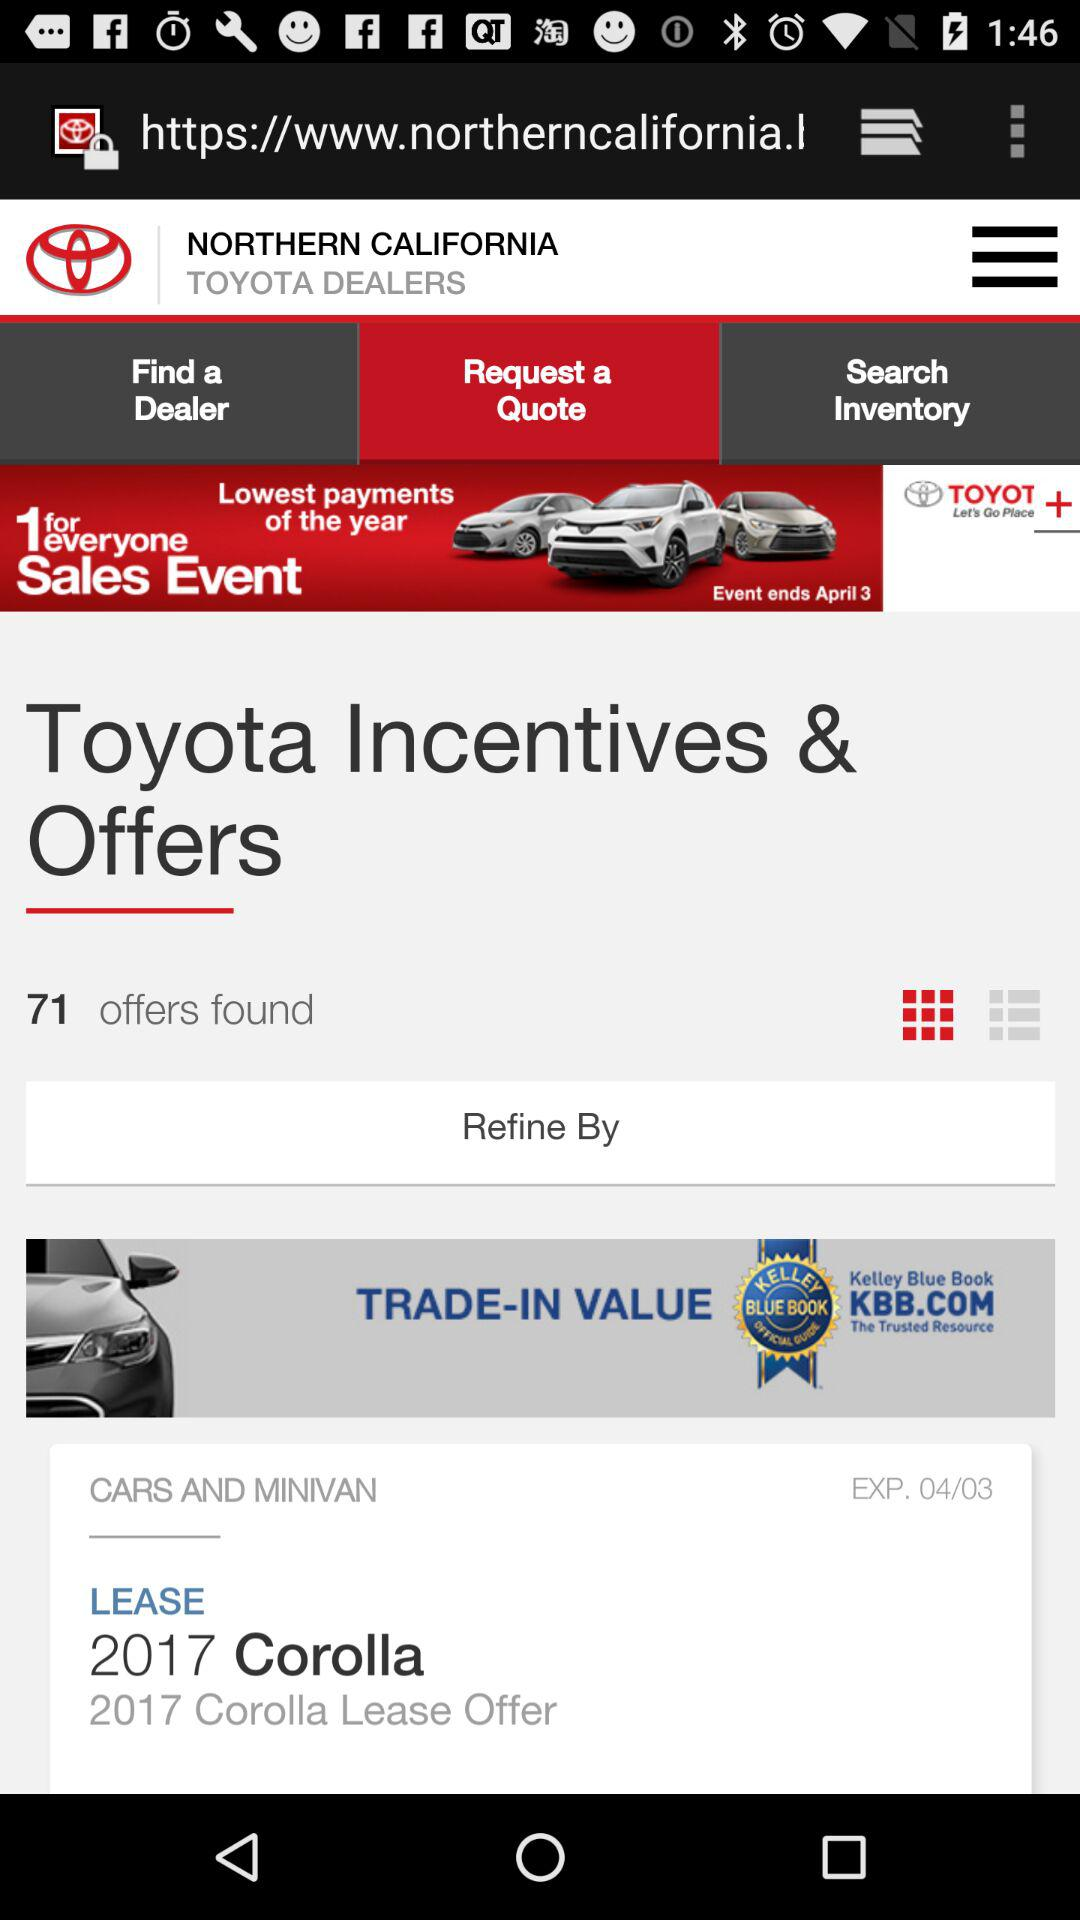Where is the nearest dealership?
When the provided information is insufficient, respond with <no answer>. <no answer> 